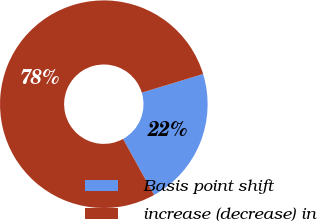<chart> <loc_0><loc_0><loc_500><loc_500><pie_chart><fcel>Basis point shift<fcel>increase (decrease) in<nl><fcel>21.65%<fcel>78.35%<nl></chart> 